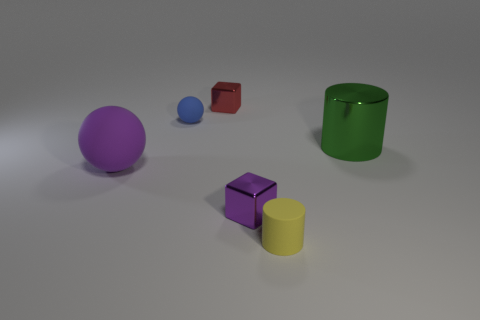Add 3 big cyan metallic cubes. How many objects exist? 9 Subtract all cylinders. How many objects are left? 4 Add 6 big rubber things. How many big rubber things are left? 7 Add 1 cyan objects. How many cyan objects exist? 1 Subtract 0 blue cylinders. How many objects are left? 6 Subtract all purple cubes. Subtract all green metallic objects. How many objects are left? 4 